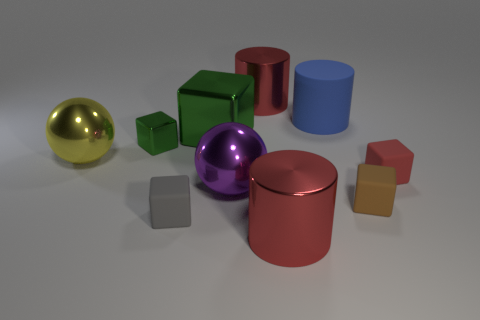Subtract all gray blocks. How many blocks are left? 4 Subtract all tiny shiny cubes. How many cubes are left? 4 Subtract all blue cubes. Subtract all yellow balls. How many cubes are left? 5 Subtract all spheres. How many objects are left? 8 Add 2 small gray things. How many small gray things are left? 3 Add 10 small blue shiny cylinders. How many small blue shiny cylinders exist? 10 Subtract 1 gray cubes. How many objects are left? 9 Subtract all tiny green matte objects. Subtract all big blue cylinders. How many objects are left? 9 